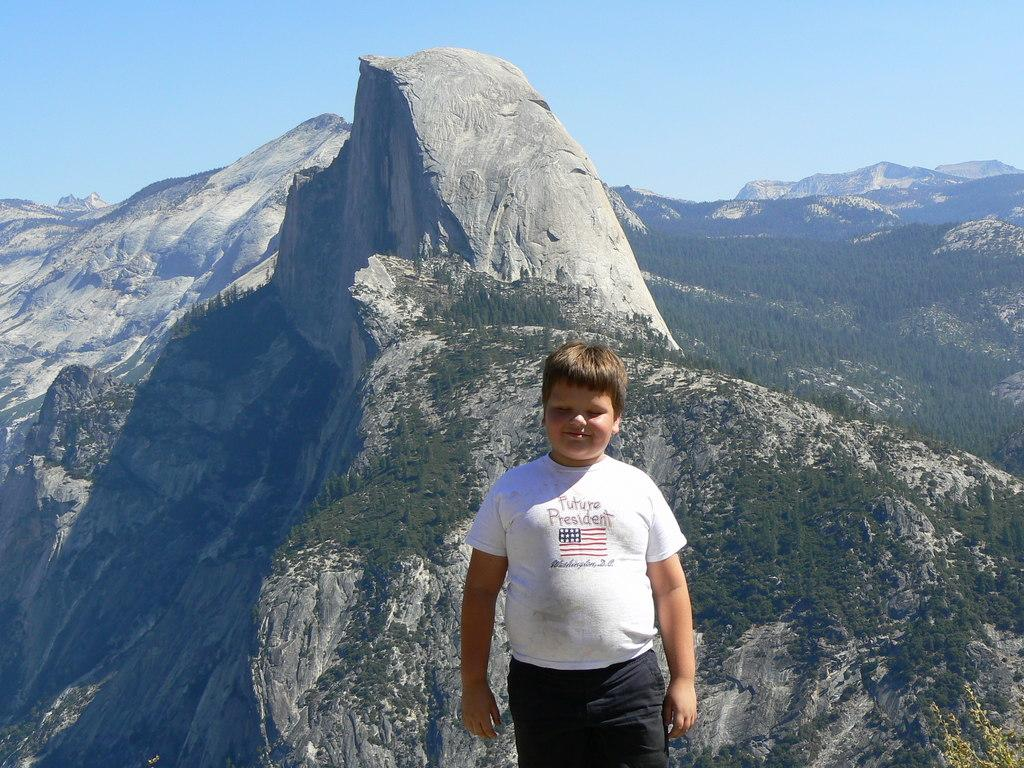What is the setting of the image? The image has an outside view. Who or what can be seen in the image? There is a kid at the bottom of the image. What is the kid wearing? The kid is wearing clothes. What is behind the kid in the image? The kid is standing in front of a hill. What can be seen at the top of the image? There is a sky at the top of the image. What effect does the gold have on the kid in the image? There is no gold present in the image, so it cannot have any effect on the kid. 